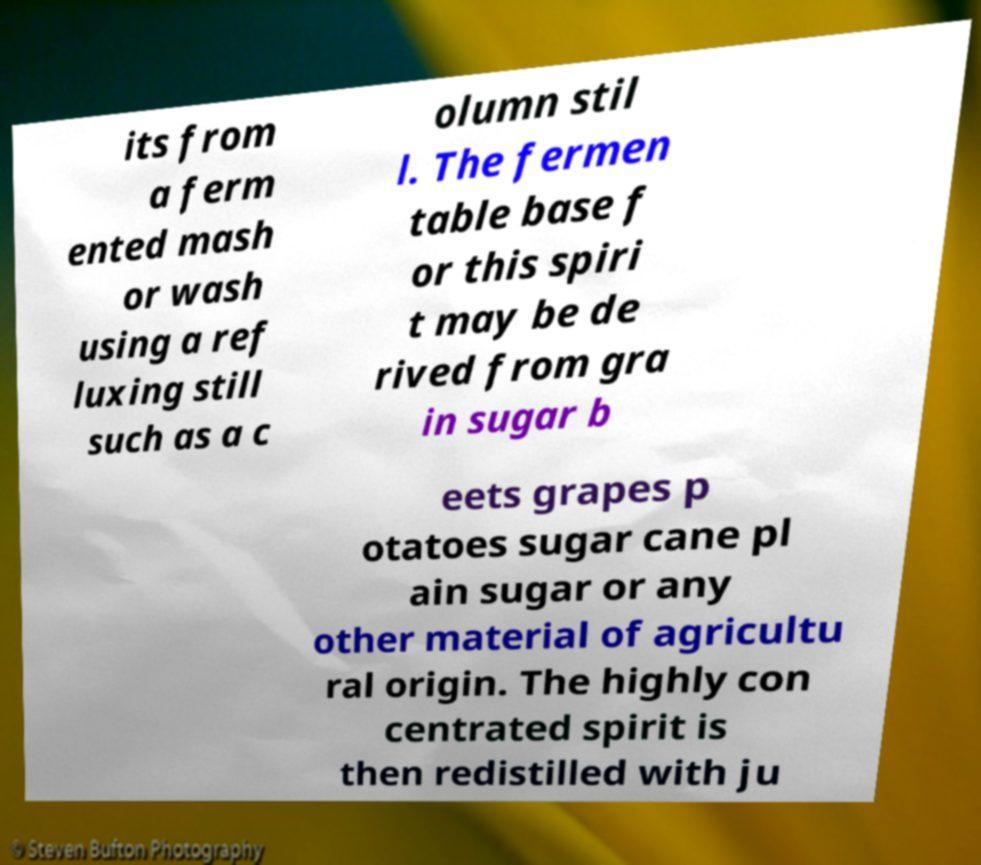Could you extract and type out the text from this image? its from a ferm ented mash or wash using a ref luxing still such as a c olumn stil l. The fermen table base f or this spiri t may be de rived from gra in sugar b eets grapes p otatoes sugar cane pl ain sugar or any other material of agricultu ral origin. The highly con centrated spirit is then redistilled with ju 